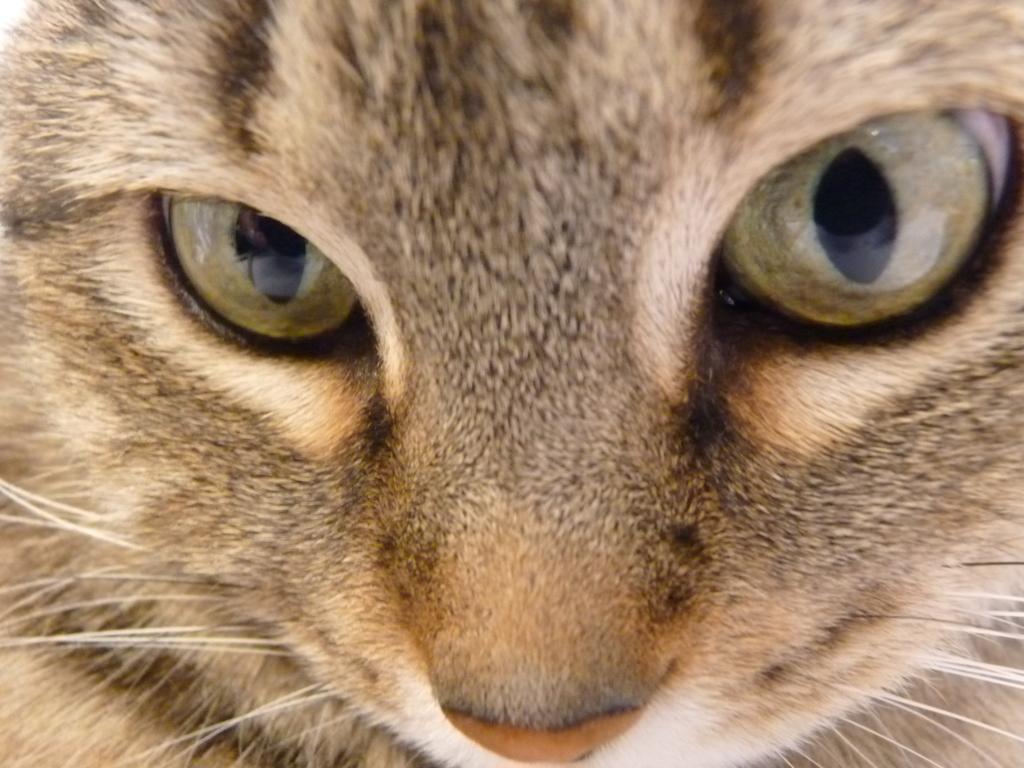Please provide a concise description of this image. In this picture we can see an animal face with eyes and nose. 